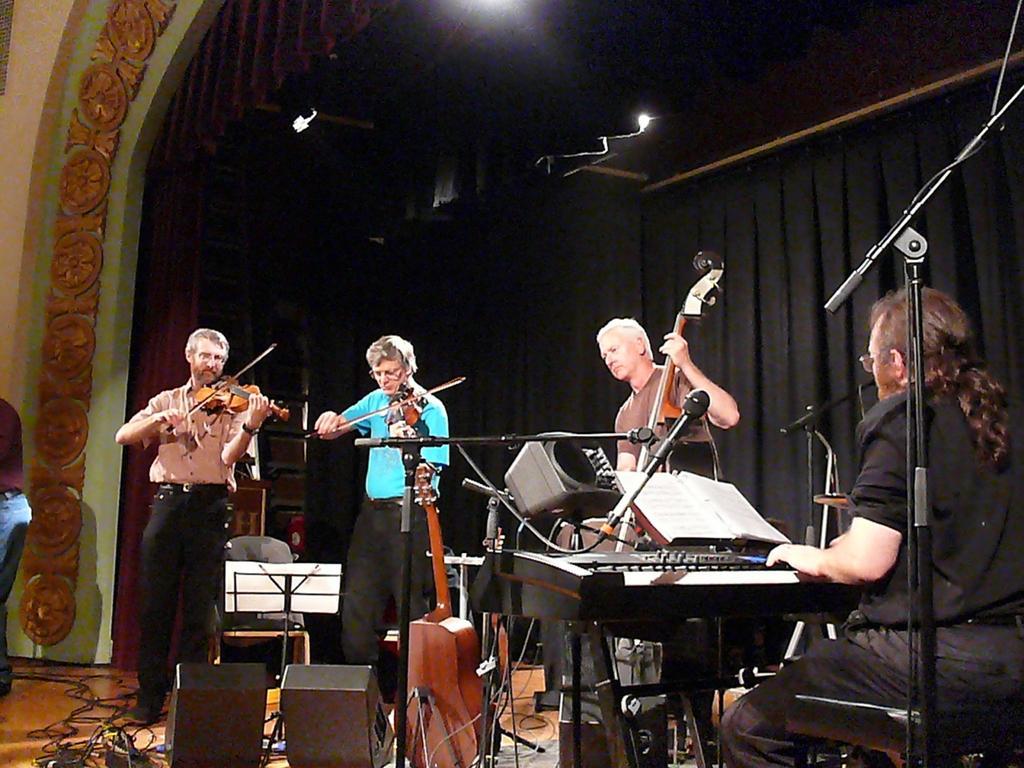How would you summarize this image in a sentence or two? In this image I can see there are three men standing on the stage and playing musical instrument in front of the microphone and on the right side of the image we have a man who is sitting on a chair and playing musical instrument in front of the mic. Behind this people we have a black color curtain. 